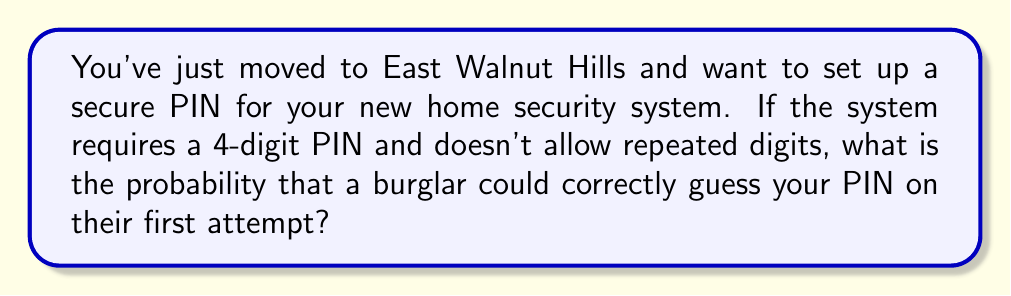Solve this math problem. Let's approach this step-by-step:

1) First, we need to calculate the total number of possible 4-digit PINs without repetition.

2) For the first digit, we have 10 choices (0-9).

3) For the second digit, we have 9 choices (all digits except the one used for the first digit).

4) For the third digit, we have 8 choices.

5) For the fourth digit, we have 7 choices.

6) Therefore, the total number of possible PINs is:

   $$10 \times 9 \times 8 \times 7 = 5040$$

7) The probability of correctly guessing the PIN on the first attempt is:

   $$P(\text{correct guess}) = \frac{\text{number of favorable outcomes}}{\text{total number of possible outcomes}}$$

8) There is only one correct PIN out of 5040 possible PINs, so:

   $$P(\text{correct guess}) = \frac{1}{5040} \approx 0.000198$$
Answer: $\frac{1}{5040}$ or approximately $0.000198$ 